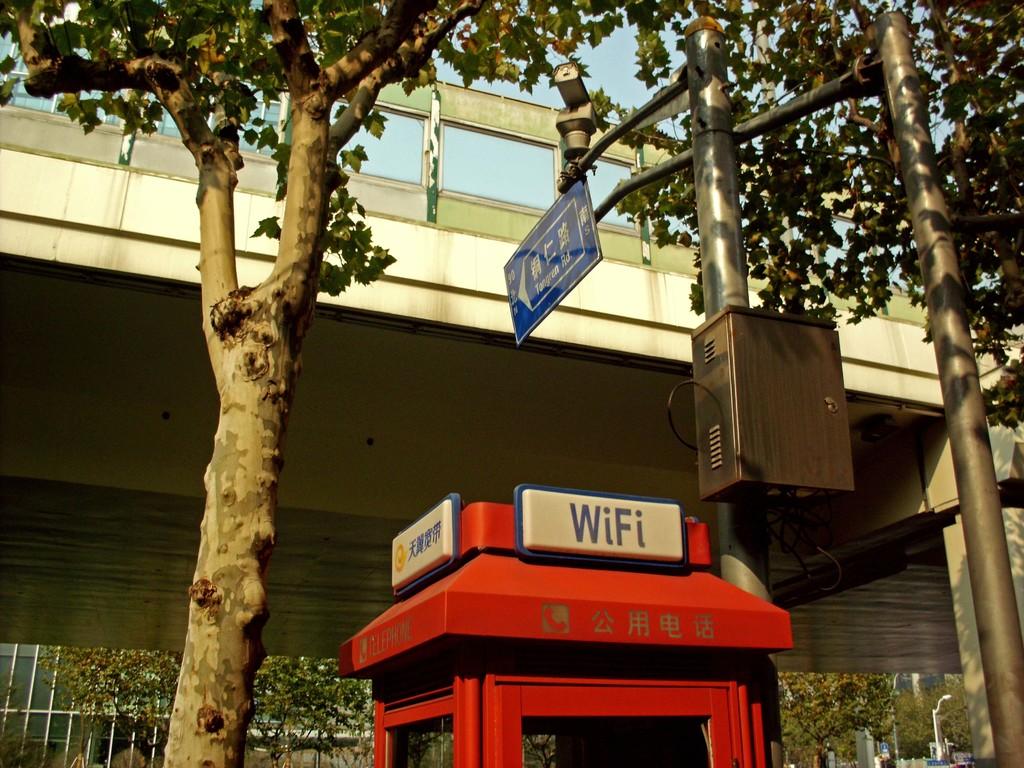What is offered in this phone booth?
Your response must be concise. Wifi. 